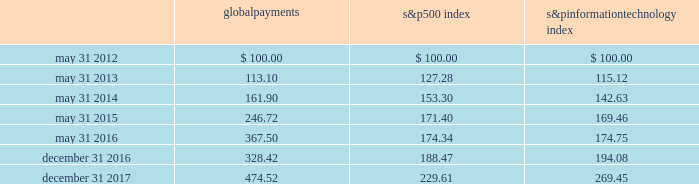Stock performance graph the following graph compares our cumulative shareholder returns with the standard & poor 2019s information technology index and the standard & poor 2019s 500 index for the year ended december 31 , 2017 , the 2016 fiscal transition period , and the years ended may 31 , 2016 , 2015 , 2014 and 2013 .
The line graph assumes the investment of $ 100 in our common stock , the standard & poor 2019s 500 index and the standard & poor 2019s information technology index on may 31 , 2012 and assumes reinvestment of all dividends .
5/12 5/165/155/145/13 global payments inc .
S&p 500 s&p information technology 12/16 12/17 comparison of 5 year cumulative total return* among global payments inc. , the s&p 500 index and the s&p information technology index * $ 100 invested on may 31 , 2012 in stock or index , including reinvestment of dividends .
Copyright a9 2018 standard & poor 2019s , a division of s&p global .
All rights reserved .
Global payments 500 index information technology .
30 2013 global payments inc .
| 2017 form 10-k annual report .
What was the percentage gained by investing $ 100 into global payments in comparison to the technology index? 
Rationale: to find the comparison of gains between the two stocks one must find the percentage gain for each individual stock . then one must subtract these two percentage gains from each other .
Computations: ((474.52 - 100) - (269.45 - 100))
Answer: 205.07. 